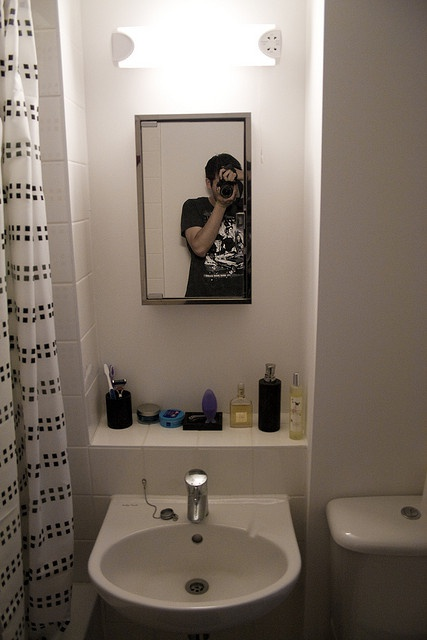Describe the objects in this image and their specific colors. I can see sink in darkgray, gray, and black tones, toilet in darkgray, black, and gray tones, people in darkgray, black, gray, and maroon tones, bottle in darkgray, black, and gray tones, and bottle in darkgray, gray, and olive tones in this image. 